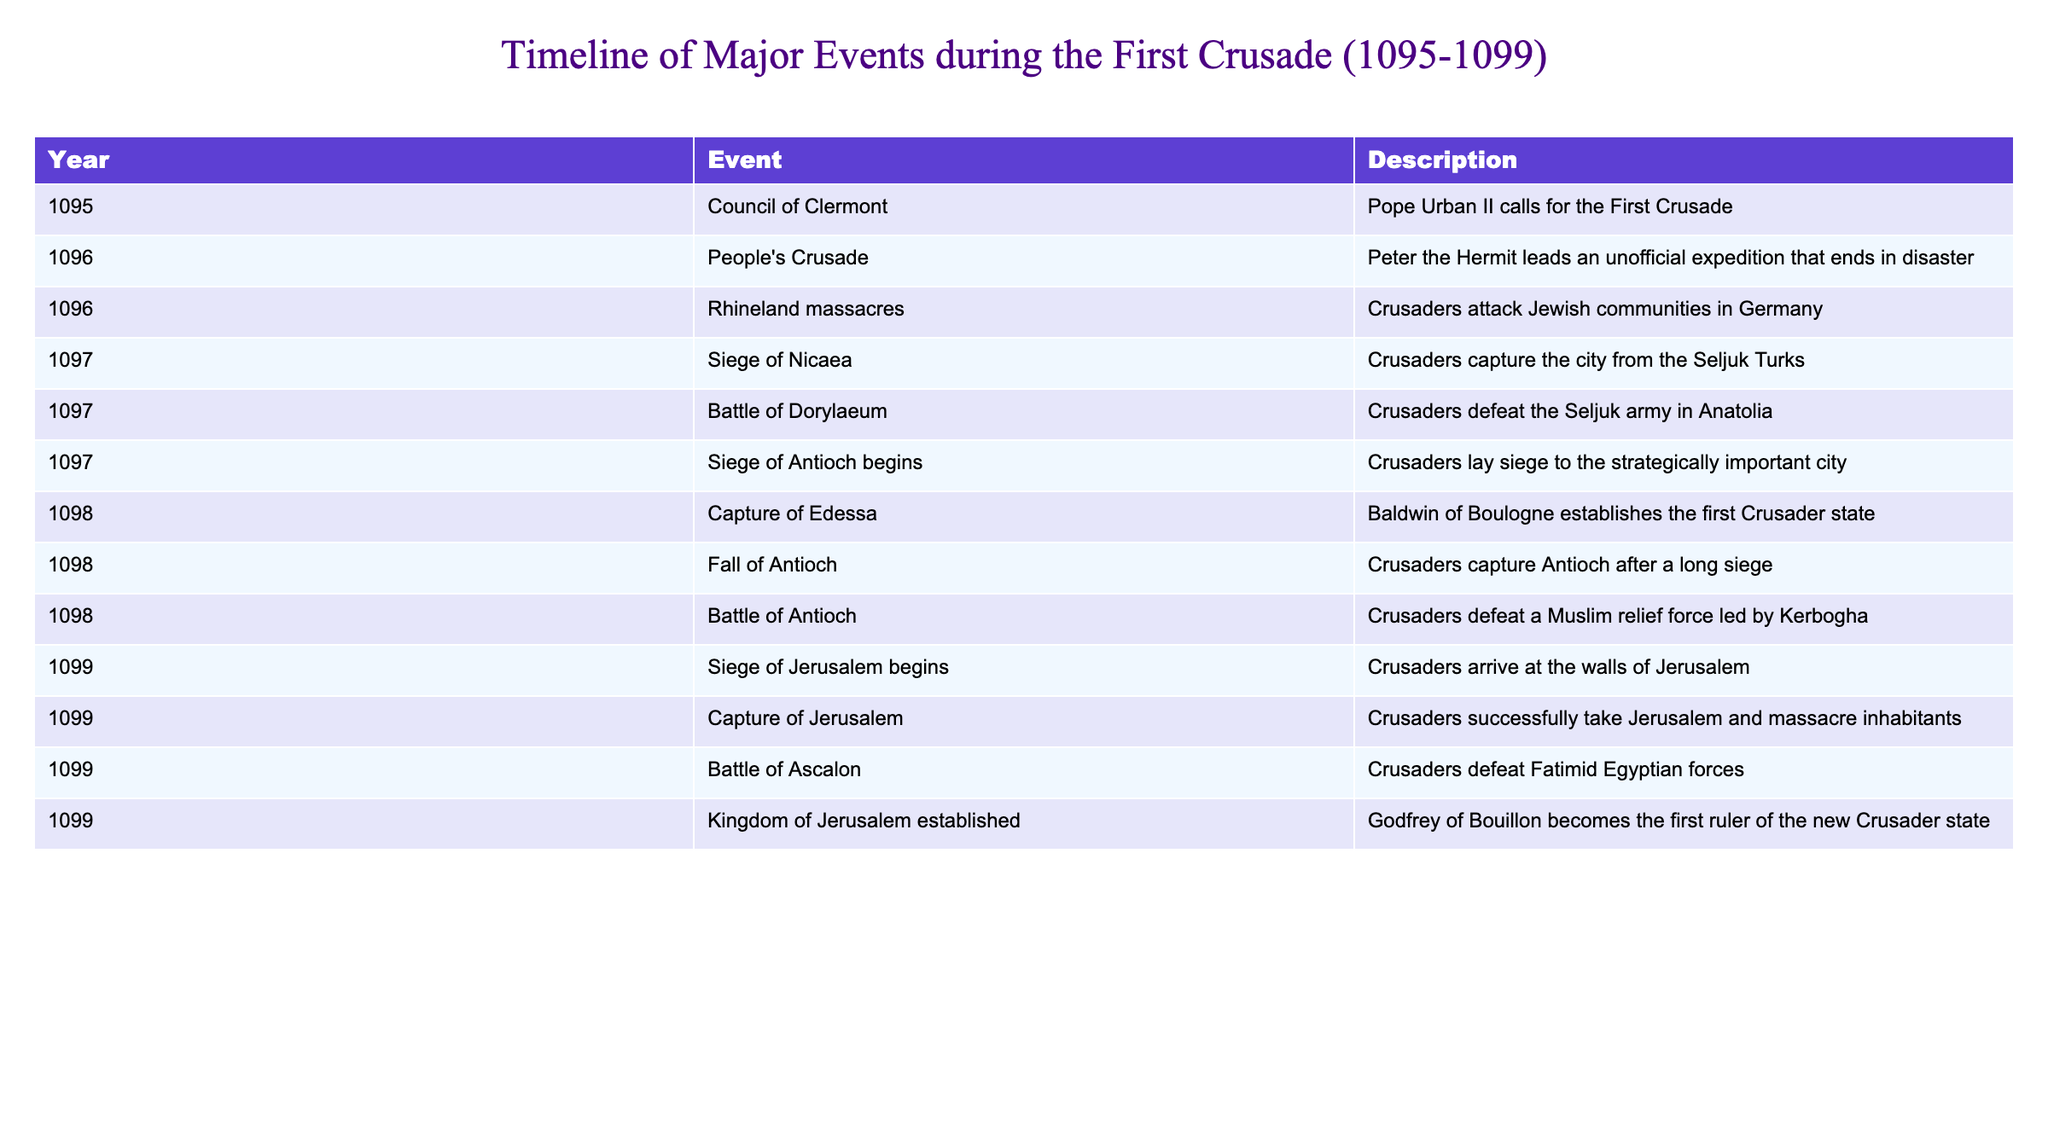What year did the Council of Clermont take place? The table indicates that the Council of Clermont occurred in 1095. This is clearly labeled in the “Year” column adjacent to the event name in the “Event” column.
Answer: 1095 How many major events occurred in the year 1098? By reviewing the table, I see that there are three events listed for the year 1098: the Capture of Edessa, the Fall of Antioch, and the Battle of Antioch. Therefore, the count is three.
Answer: 3 Did the Crusaders successfully capture Jerusalem in 1099? The table shows that the event labeled "Capture of Jerusalem" occurred in 1099, indicating a successful capture. The description confirms that they took Jerusalem and massacred its inhabitants, which supports a "yes" answer.
Answer: Yes What was the first Crusader state established, and in what year? The table indicates that the first Crusader state, Edessa, was established in 1098, as noted next to the event "Capture of Edessa." The mention of Baldwin of Boulogne also connects this state to the creation of existing political authority during the Crusade.
Answer: Edessa, 1098 How many battles were fought by the Crusaders during the First Crusade based on this table? The table presents three battles explicitly: the Battle of Dorylaeum, the Battle of Antioch, and the Battle of Ascalon, which are listed in the corresponding "Event" column. Adding these gives a total of three battles.
Answer: 3 What is the time span of the First Crusade according to the timeline? The first event is in 1095, and the last event is in 1099, thus the time span is the difference between the two years, calculated as 1099 - 1095, which equals four years (from the beginning of 1095 to the end of 1099).
Answer: 4 years Which event marked the beginning of the Siege of Jerusalem, and when did it occur? The table states that the Siege of Jerusalem began in 1099. This is directly labeled, and refers to the event before the eventual Capture of Jerusalem later in the same year, indicating it is the start of that significant military action.
Answer: Siege of Jerusalem begins, 1099 What percentage of the listed events involved battles? There are three battles out of a total of eleven events in the table (three battles: Dorylaeum, Antioch, and Ascalon). To find the percentage, I calculate (3/11) * 100, which equals approximately 27.27%.
Answer: 27.27% How many events occurred in 1096? Upon examining the table, I find two events listed for the year 1096: the People's Crusade and the Rhineland massacres. Therefore, the total is two events.
Answer: 2 